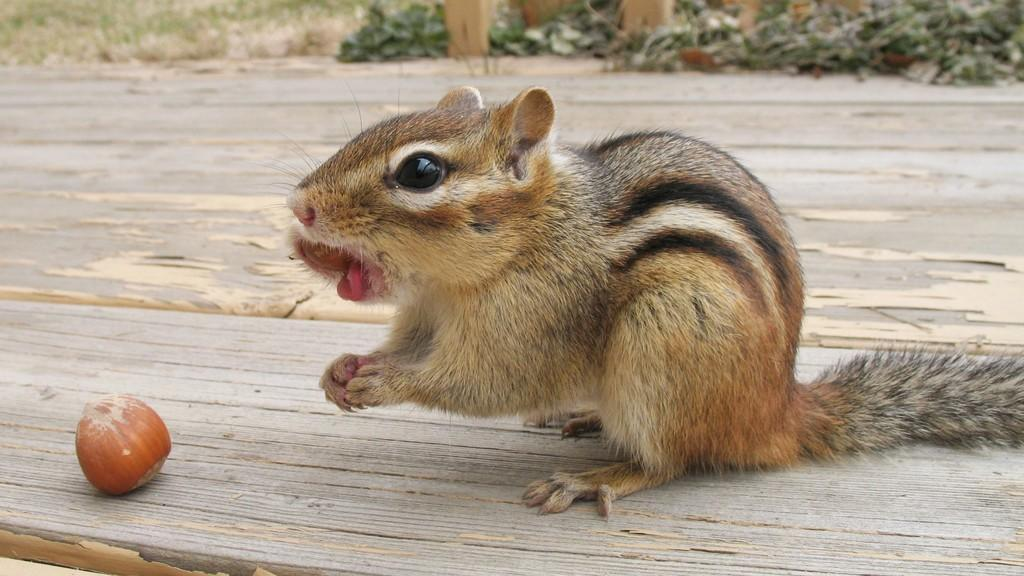What type of animal can be seen in the image? There is a squirrel in the image. What is the squirrel sitting on in the image? There is an object on a wooden object in the image. What type of natural environment is visible in the background of the image? Grass and plants are visible in the background of the image. What else can be seen in the background of the image? There are other objects in the background of the image. Can you tell me how many divisions are present in the image? There is no mention of divisions in the image, so it is not possible to determine the number of divisions. 